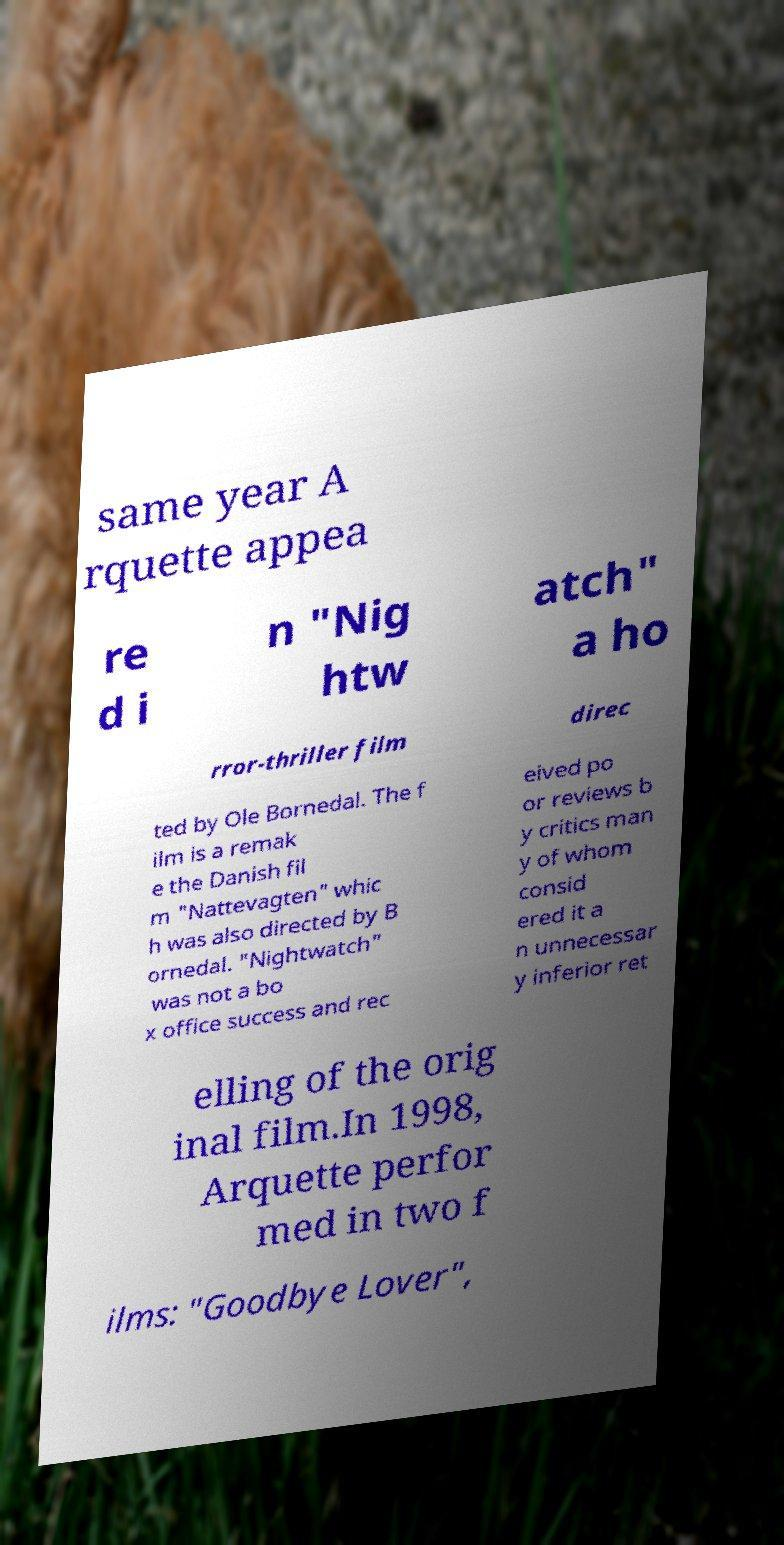For documentation purposes, I need the text within this image transcribed. Could you provide that? same year A rquette appea re d i n "Nig htw atch" a ho rror-thriller film direc ted by Ole Bornedal. The f ilm is a remak e the Danish fil m "Nattevagten" whic h was also directed by B ornedal. "Nightwatch" was not a bo x office success and rec eived po or reviews b y critics man y of whom consid ered it a n unnecessar y inferior ret elling of the orig inal film.In 1998, Arquette perfor med in two f ilms: "Goodbye Lover", 